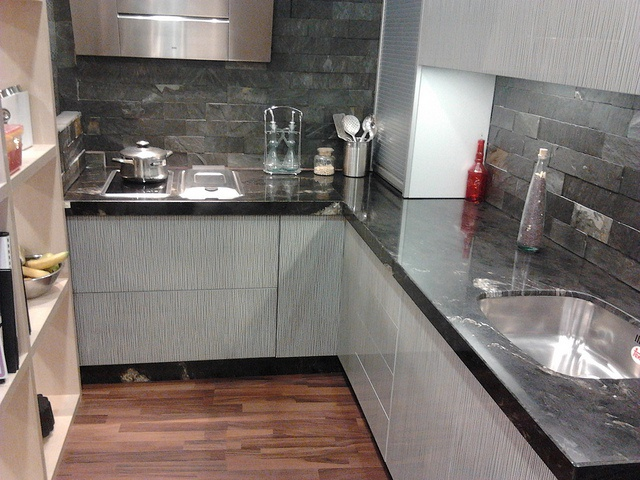Describe the objects in this image and their specific colors. I can see oven in brown, gray, darkgray, and lightgray tones, sink in brown, darkgray, lightgray, and gray tones, cup in brown, gray, black, darkgray, and lightgray tones, bottle in brown, gray, darkgray, and black tones, and bowl in brown, tan, gray, and darkgray tones in this image. 